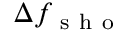Convert formula to latex. <formula><loc_0><loc_0><loc_500><loc_500>\Delta f _ { s h o }</formula> 